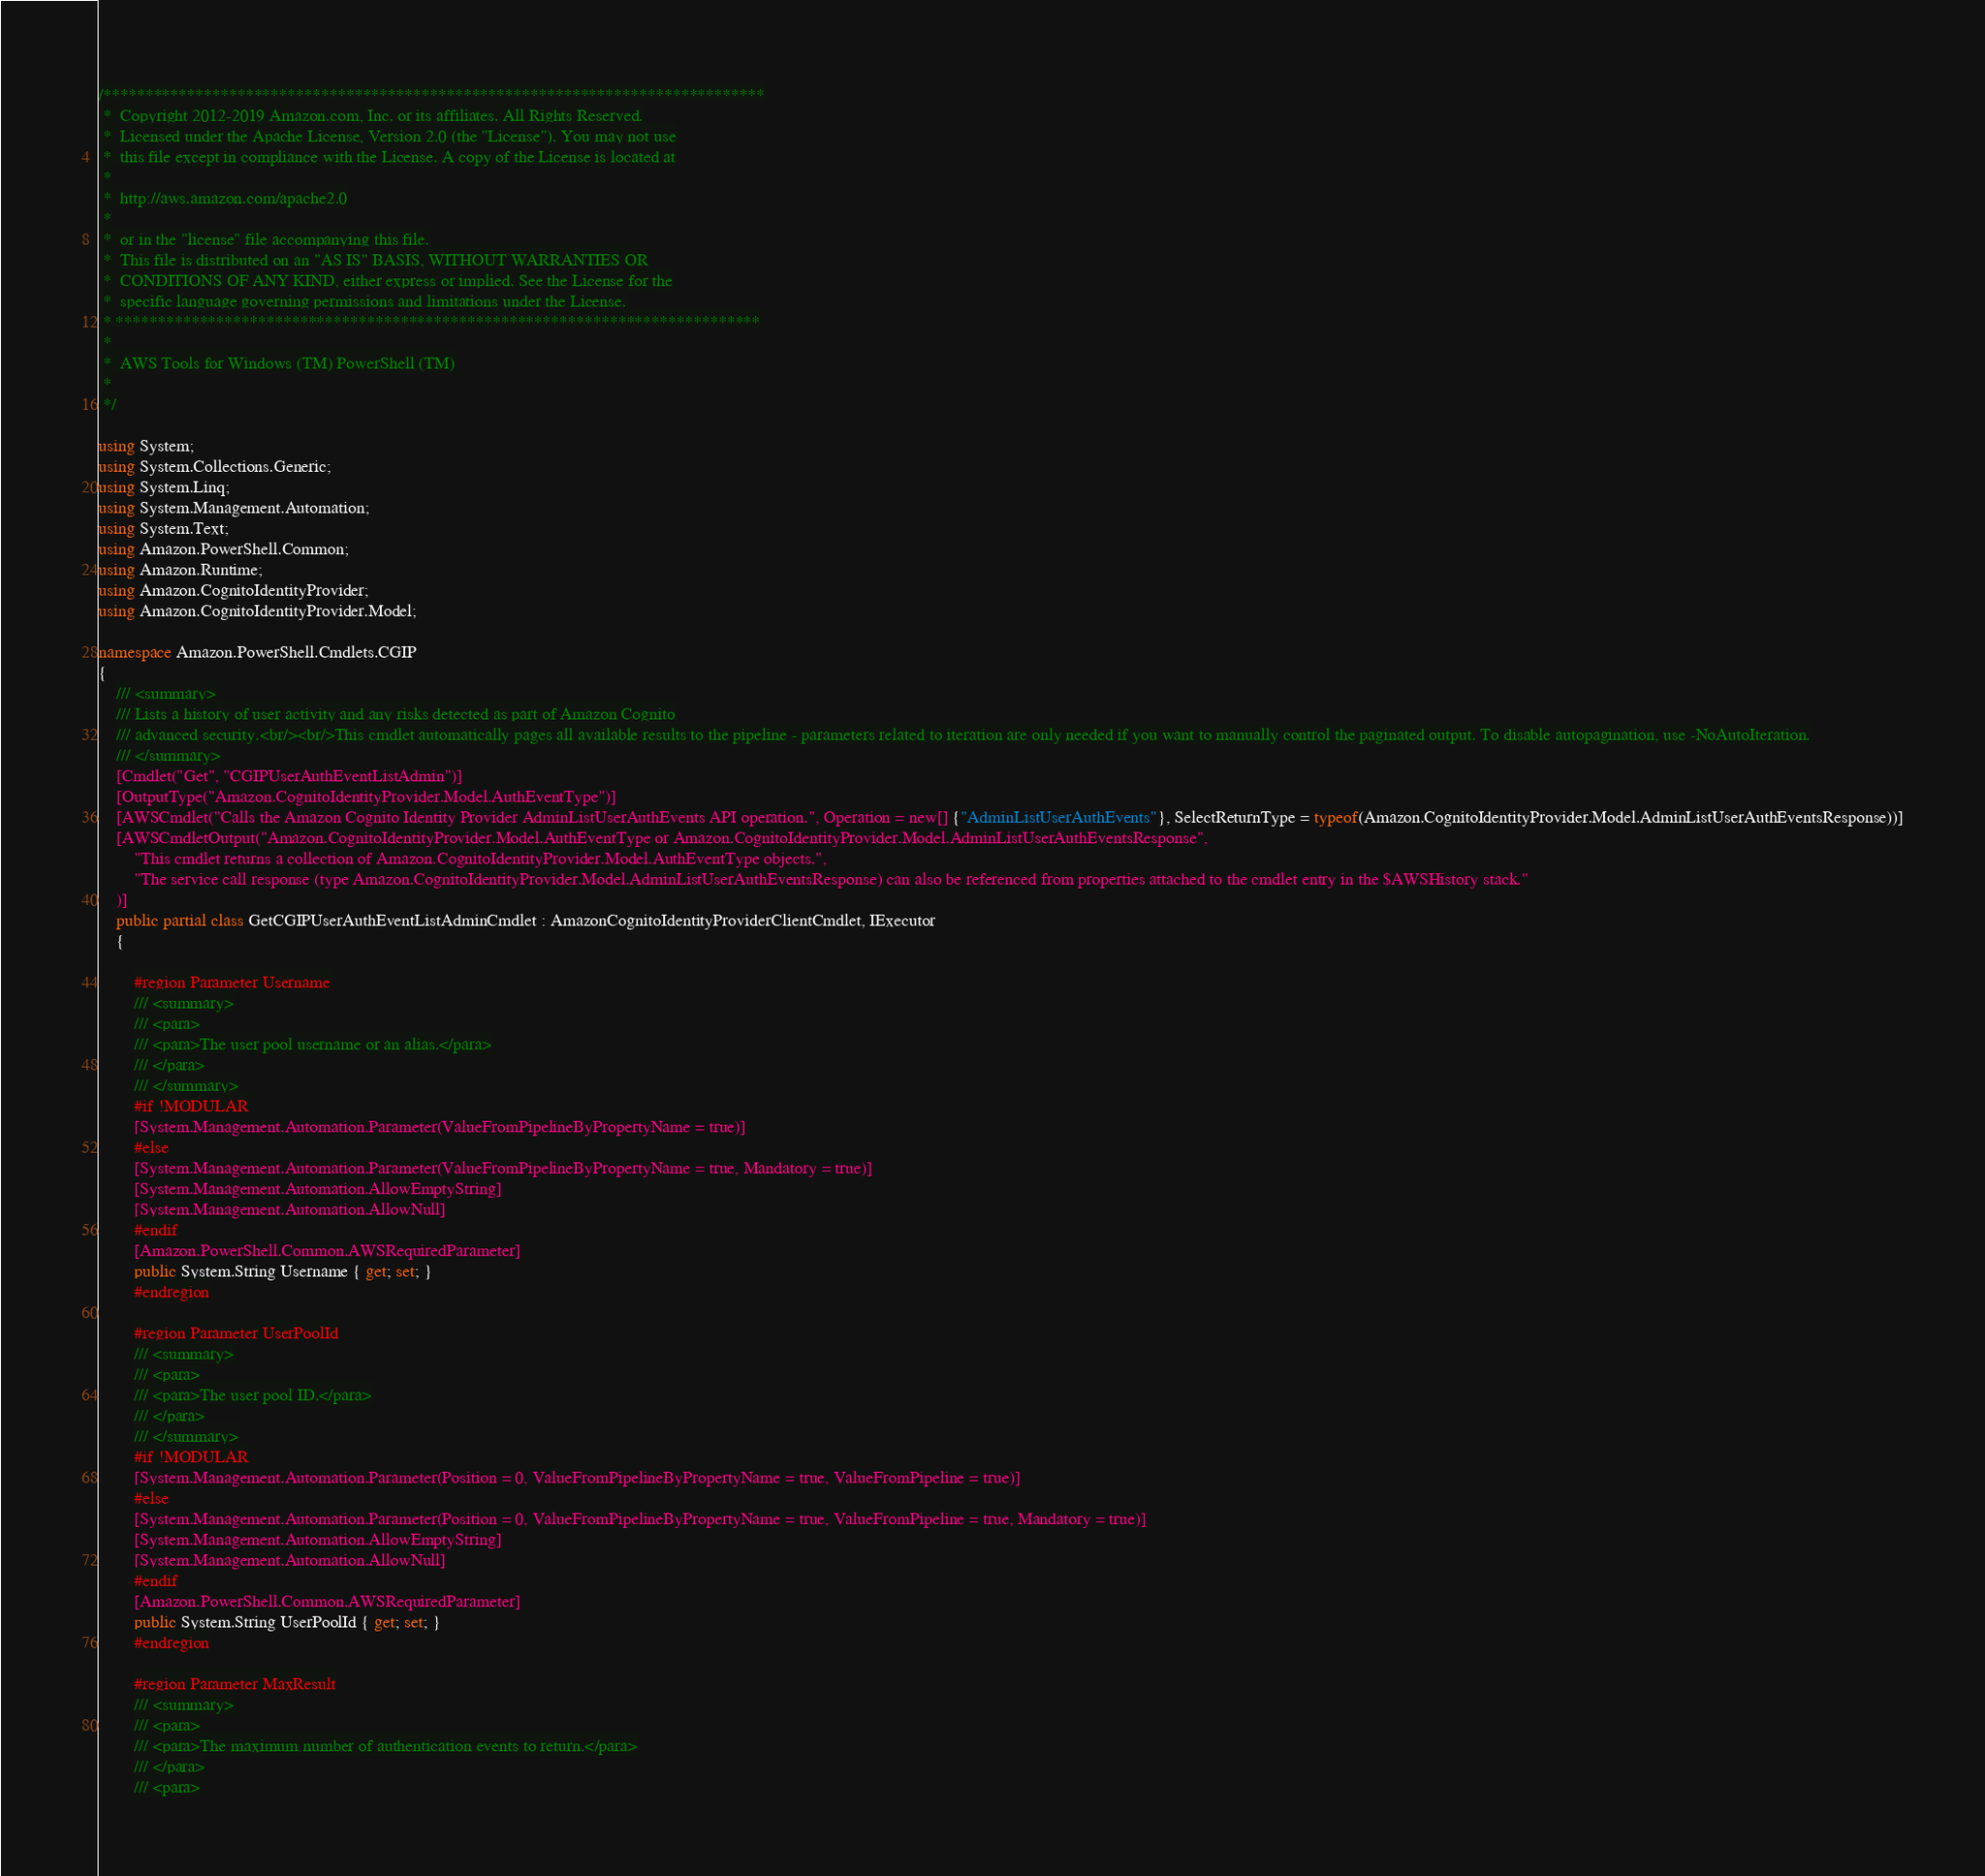Convert code to text. <code><loc_0><loc_0><loc_500><loc_500><_C#_>/*******************************************************************************
 *  Copyright 2012-2019 Amazon.com, Inc. or its affiliates. All Rights Reserved.
 *  Licensed under the Apache License, Version 2.0 (the "License"). You may not use
 *  this file except in compliance with the License. A copy of the License is located at
 *
 *  http://aws.amazon.com/apache2.0
 *
 *  or in the "license" file accompanying this file.
 *  This file is distributed on an "AS IS" BASIS, WITHOUT WARRANTIES OR
 *  CONDITIONS OF ANY KIND, either express or implied. See the License for the
 *  specific language governing permissions and limitations under the License.
 * *****************************************************************************
 *
 *  AWS Tools for Windows (TM) PowerShell (TM)
 *
 */

using System;
using System.Collections.Generic;
using System.Linq;
using System.Management.Automation;
using System.Text;
using Amazon.PowerShell.Common;
using Amazon.Runtime;
using Amazon.CognitoIdentityProvider;
using Amazon.CognitoIdentityProvider.Model;

namespace Amazon.PowerShell.Cmdlets.CGIP
{
    /// <summary>
    /// Lists a history of user activity and any risks detected as part of Amazon Cognito
    /// advanced security.<br/><br/>This cmdlet automatically pages all available results to the pipeline - parameters related to iteration are only needed if you want to manually control the paginated output. To disable autopagination, use -NoAutoIteration.
    /// </summary>
    [Cmdlet("Get", "CGIPUserAuthEventListAdmin")]
    [OutputType("Amazon.CognitoIdentityProvider.Model.AuthEventType")]
    [AWSCmdlet("Calls the Amazon Cognito Identity Provider AdminListUserAuthEvents API operation.", Operation = new[] {"AdminListUserAuthEvents"}, SelectReturnType = typeof(Amazon.CognitoIdentityProvider.Model.AdminListUserAuthEventsResponse))]
    [AWSCmdletOutput("Amazon.CognitoIdentityProvider.Model.AuthEventType or Amazon.CognitoIdentityProvider.Model.AdminListUserAuthEventsResponse",
        "This cmdlet returns a collection of Amazon.CognitoIdentityProvider.Model.AuthEventType objects.",
        "The service call response (type Amazon.CognitoIdentityProvider.Model.AdminListUserAuthEventsResponse) can also be referenced from properties attached to the cmdlet entry in the $AWSHistory stack."
    )]
    public partial class GetCGIPUserAuthEventListAdminCmdlet : AmazonCognitoIdentityProviderClientCmdlet, IExecutor
    {
        
        #region Parameter Username
        /// <summary>
        /// <para>
        /// <para>The user pool username or an alias.</para>
        /// </para>
        /// </summary>
        #if !MODULAR
        [System.Management.Automation.Parameter(ValueFromPipelineByPropertyName = true)]
        #else
        [System.Management.Automation.Parameter(ValueFromPipelineByPropertyName = true, Mandatory = true)]
        [System.Management.Automation.AllowEmptyString]
        [System.Management.Automation.AllowNull]
        #endif
        [Amazon.PowerShell.Common.AWSRequiredParameter]
        public System.String Username { get; set; }
        #endregion
        
        #region Parameter UserPoolId
        /// <summary>
        /// <para>
        /// <para>The user pool ID.</para>
        /// </para>
        /// </summary>
        #if !MODULAR
        [System.Management.Automation.Parameter(Position = 0, ValueFromPipelineByPropertyName = true, ValueFromPipeline = true)]
        #else
        [System.Management.Automation.Parameter(Position = 0, ValueFromPipelineByPropertyName = true, ValueFromPipeline = true, Mandatory = true)]
        [System.Management.Automation.AllowEmptyString]
        [System.Management.Automation.AllowNull]
        #endif
        [Amazon.PowerShell.Common.AWSRequiredParameter]
        public System.String UserPoolId { get; set; }
        #endregion
        
        #region Parameter MaxResult
        /// <summary>
        /// <para>
        /// <para>The maximum number of authentication events to return.</para>
        /// </para>
        /// <para></code> 